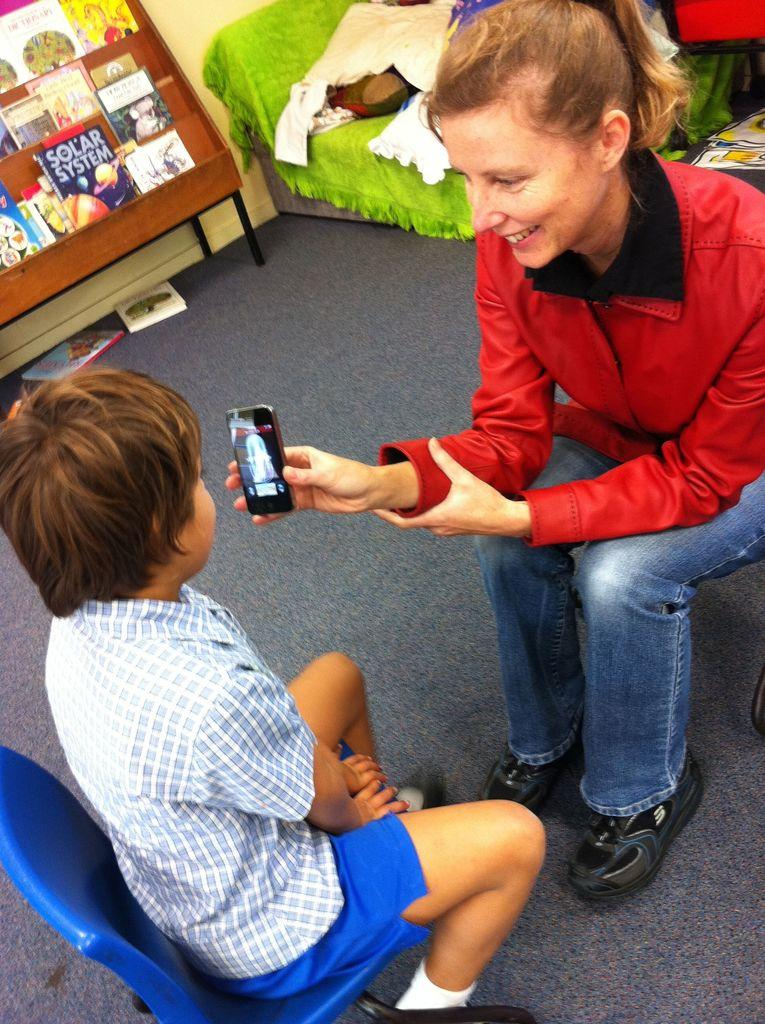<image>
Render a clear and concise summary of the photo. A woman showing a child a phone screen with a Solar System magazine in the background. 